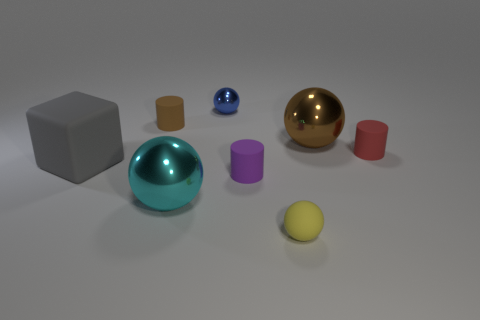Add 2 big rubber objects. How many objects exist? 10 Subtract all cubes. How many objects are left? 7 Add 1 big brown balls. How many big brown balls are left? 2 Add 7 blue spheres. How many blue spheres exist? 8 Subtract 0 blue cylinders. How many objects are left? 8 Subtract all tiny brown rubber objects. Subtract all brown metal objects. How many objects are left? 6 